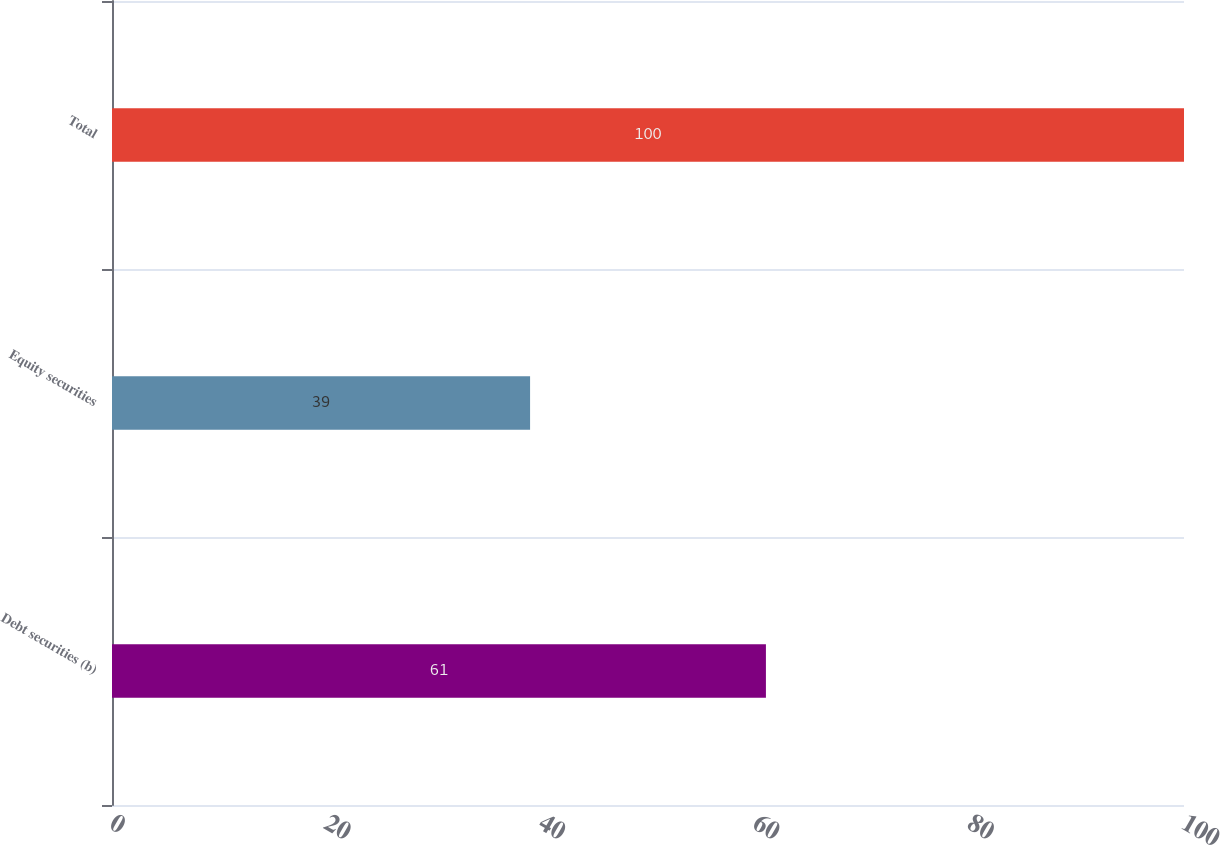<chart> <loc_0><loc_0><loc_500><loc_500><bar_chart><fcel>Debt securities (b)<fcel>Equity securities<fcel>Total<nl><fcel>61<fcel>39<fcel>100<nl></chart> 